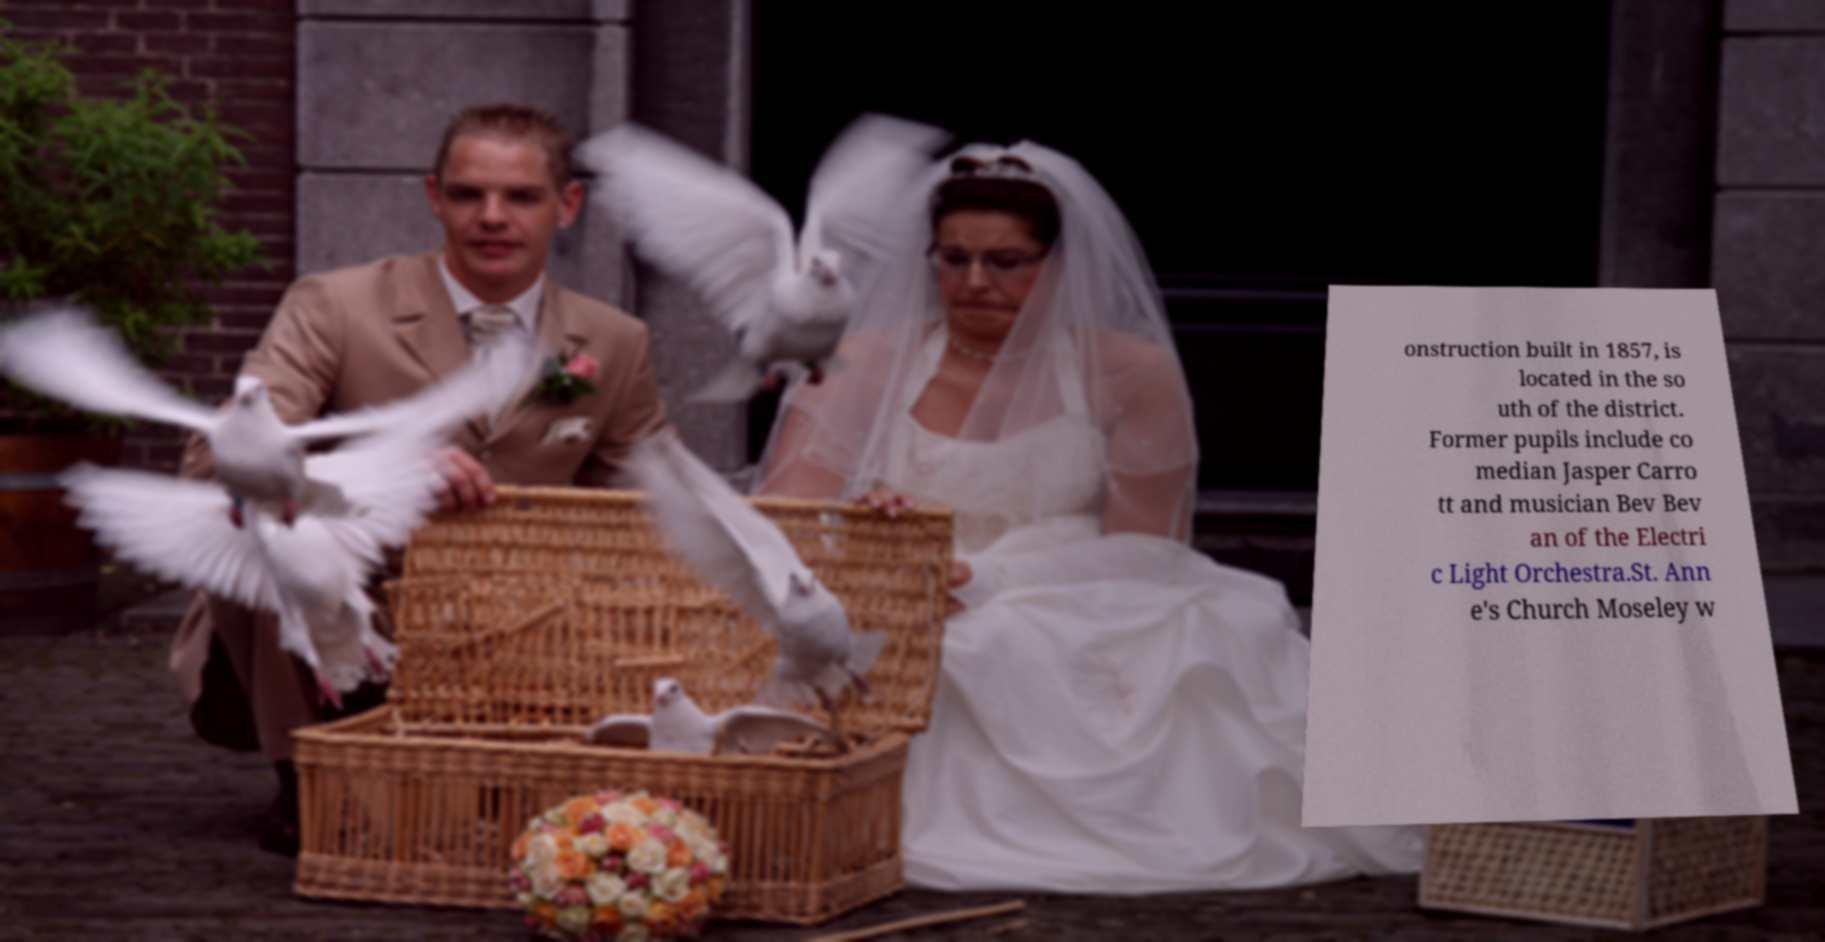There's text embedded in this image that I need extracted. Can you transcribe it verbatim? onstruction built in 1857, is located in the so uth of the district. Former pupils include co median Jasper Carro tt and musician Bev Bev an of the Electri c Light Orchestra.St. Ann e's Church Moseley w 